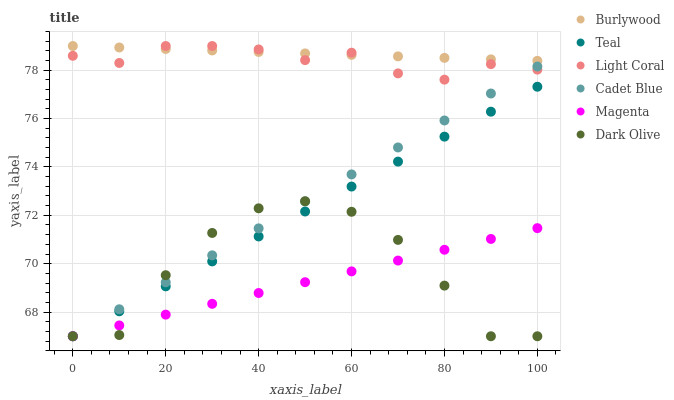Does Magenta have the minimum area under the curve?
Answer yes or no. Yes. Does Burlywood have the maximum area under the curve?
Answer yes or no. Yes. Does Dark Olive have the minimum area under the curve?
Answer yes or no. No. Does Dark Olive have the maximum area under the curve?
Answer yes or no. No. Is Teal the smoothest?
Answer yes or no. Yes. Is Dark Olive the roughest?
Answer yes or no. Yes. Is Burlywood the smoothest?
Answer yes or no. No. Is Burlywood the roughest?
Answer yes or no. No. Does Cadet Blue have the lowest value?
Answer yes or no. Yes. Does Burlywood have the lowest value?
Answer yes or no. No. Does Light Coral have the highest value?
Answer yes or no. Yes. Does Dark Olive have the highest value?
Answer yes or no. No. Is Teal less than Light Coral?
Answer yes or no. Yes. Is Burlywood greater than Magenta?
Answer yes or no. Yes. Does Cadet Blue intersect Light Coral?
Answer yes or no. Yes. Is Cadet Blue less than Light Coral?
Answer yes or no. No. Is Cadet Blue greater than Light Coral?
Answer yes or no. No. Does Teal intersect Light Coral?
Answer yes or no. No. 